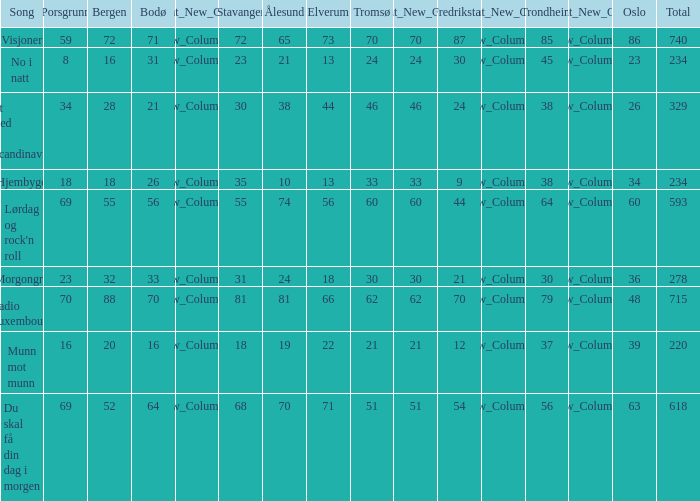What is the lowest total? 220.0. 